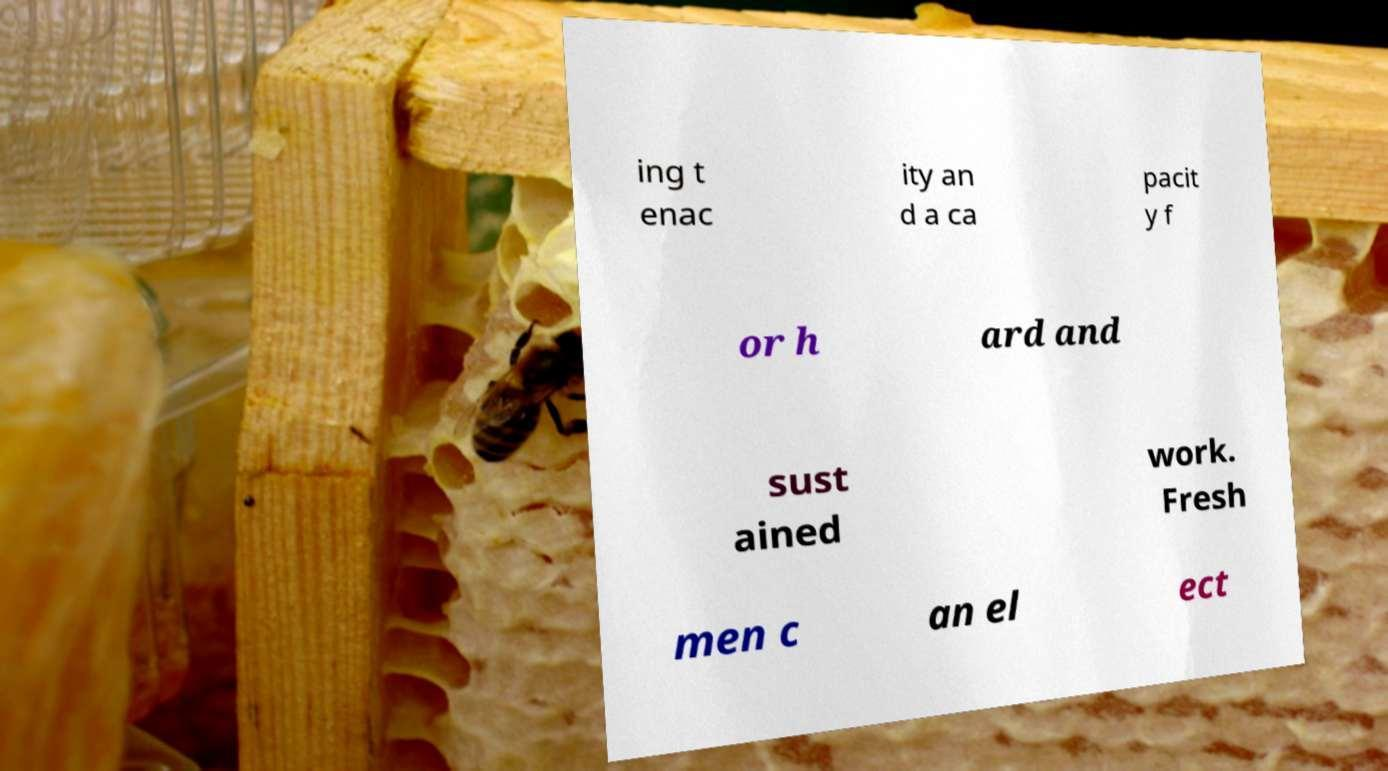Could you assist in decoding the text presented in this image and type it out clearly? ing t enac ity an d a ca pacit y f or h ard and sust ained work. Fresh men c an el ect 